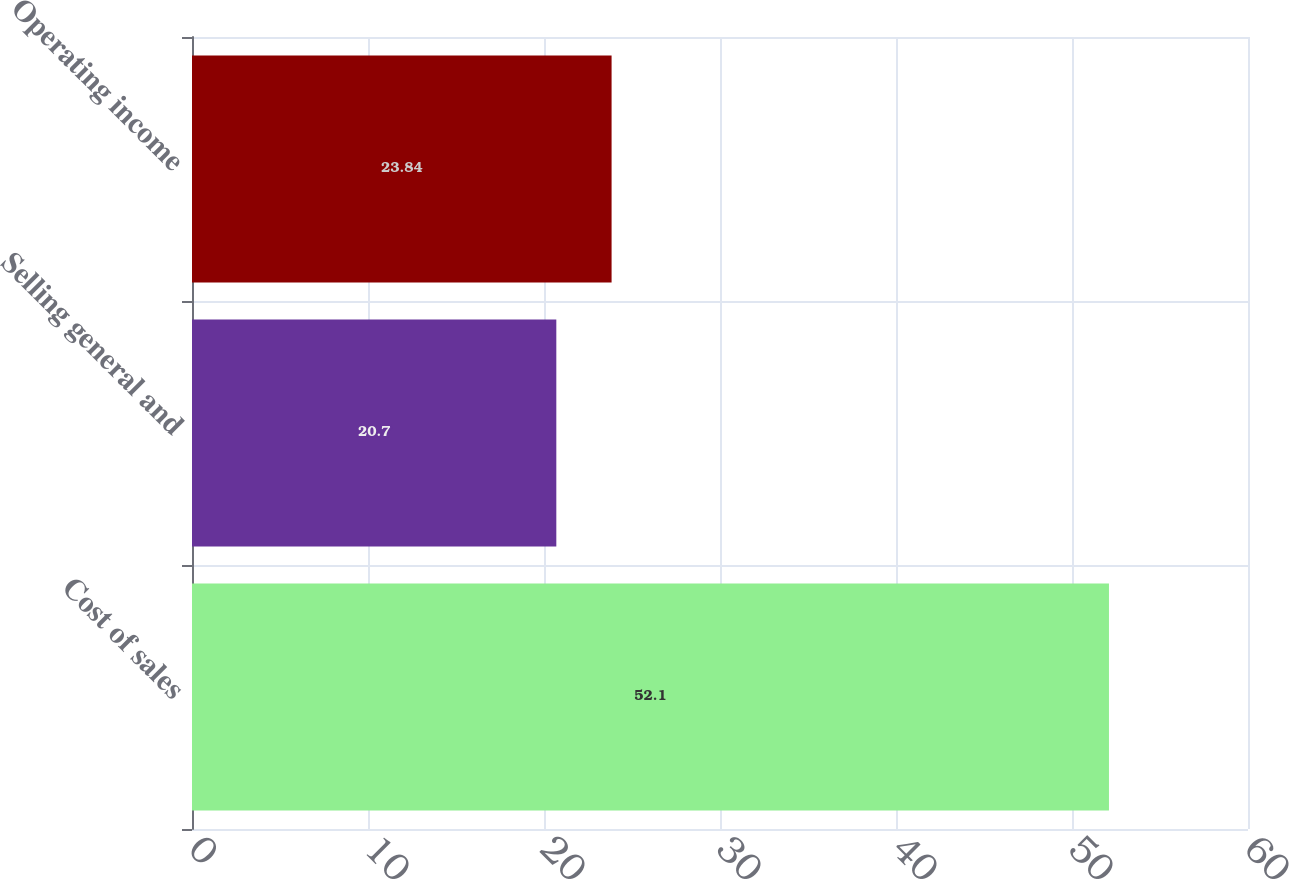Convert chart. <chart><loc_0><loc_0><loc_500><loc_500><bar_chart><fcel>Cost of sales<fcel>Selling general and<fcel>Operating income<nl><fcel>52.1<fcel>20.7<fcel>23.84<nl></chart> 